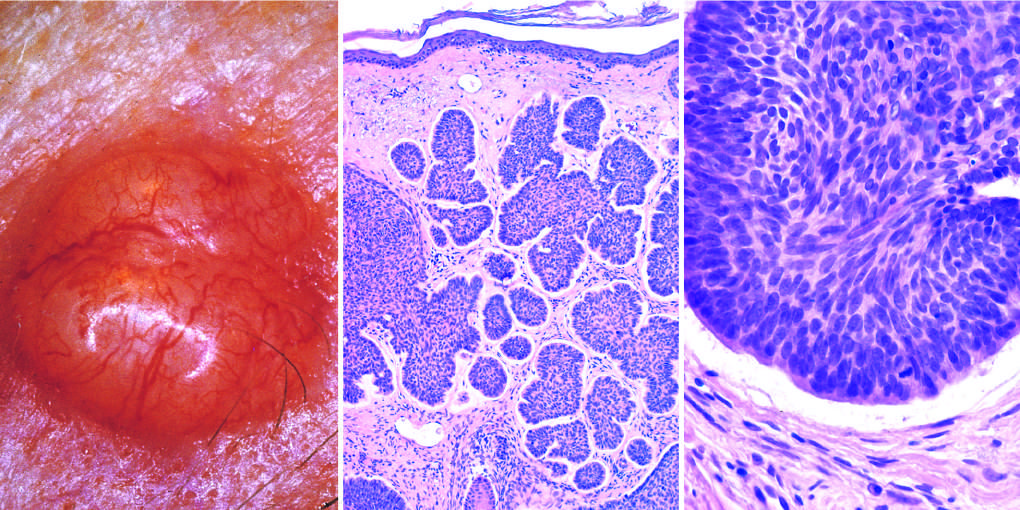what is a highly characteristic artifact of sectioning?
Answer the question using a single word or phrase. The cleft between the tumor cells and the stroma 